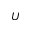<formula> <loc_0><loc_0><loc_500><loc_500>U</formula> 